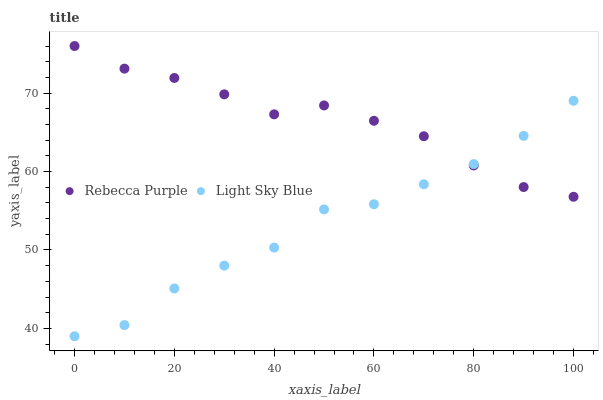Does Light Sky Blue have the minimum area under the curve?
Answer yes or no. Yes. Does Rebecca Purple have the maximum area under the curve?
Answer yes or no. Yes. Does Rebecca Purple have the minimum area under the curve?
Answer yes or no. No. Is Rebecca Purple the smoothest?
Answer yes or no. Yes. Is Light Sky Blue the roughest?
Answer yes or no. Yes. Is Rebecca Purple the roughest?
Answer yes or no. No. Does Light Sky Blue have the lowest value?
Answer yes or no. Yes. Does Rebecca Purple have the lowest value?
Answer yes or no. No. Does Rebecca Purple have the highest value?
Answer yes or no. Yes. Does Rebecca Purple intersect Light Sky Blue?
Answer yes or no. Yes. Is Rebecca Purple less than Light Sky Blue?
Answer yes or no. No. Is Rebecca Purple greater than Light Sky Blue?
Answer yes or no. No. 